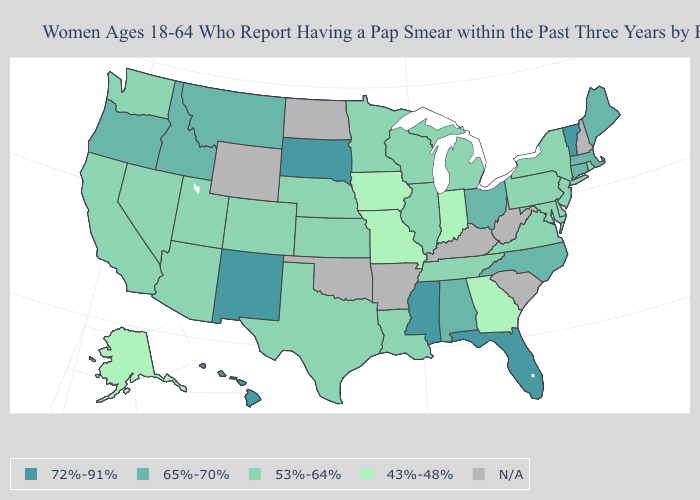Is the legend a continuous bar?
Answer briefly. No. Does the first symbol in the legend represent the smallest category?
Keep it brief. No. What is the value of Illinois?
Give a very brief answer. 53%-64%. Does Vermont have the highest value in the USA?
Keep it brief. Yes. Among the states that border Montana , does South Dakota have the highest value?
Keep it brief. Yes. Name the states that have a value in the range 72%-91%?
Keep it brief. Florida, Hawaii, Mississippi, New Mexico, South Dakota, Vermont. What is the value of Wisconsin?
Answer briefly. 53%-64%. What is the highest value in the USA?
Answer briefly. 72%-91%. Name the states that have a value in the range 53%-64%?
Concise answer only. Arizona, California, Colorado, Delaware, Illinois, Kansas, Louisiana, Maryland, Michigan, Minnesota, Nebraska, Nevada, New Jersey, New York, Pennsylvania, Rhode Island, Tennessee, Texas, Utah, Virginia, Washington, Wisconsin. What is the lowest value in the USA?
Quick response, please. 43%-48%. Does Nevada have the lowest value in the West?
Write a very short answer. No. How many symbols are there in the legend?
Short answer required. 5. What is the value of New Jersey?
Be succinct. 53%-64%. 